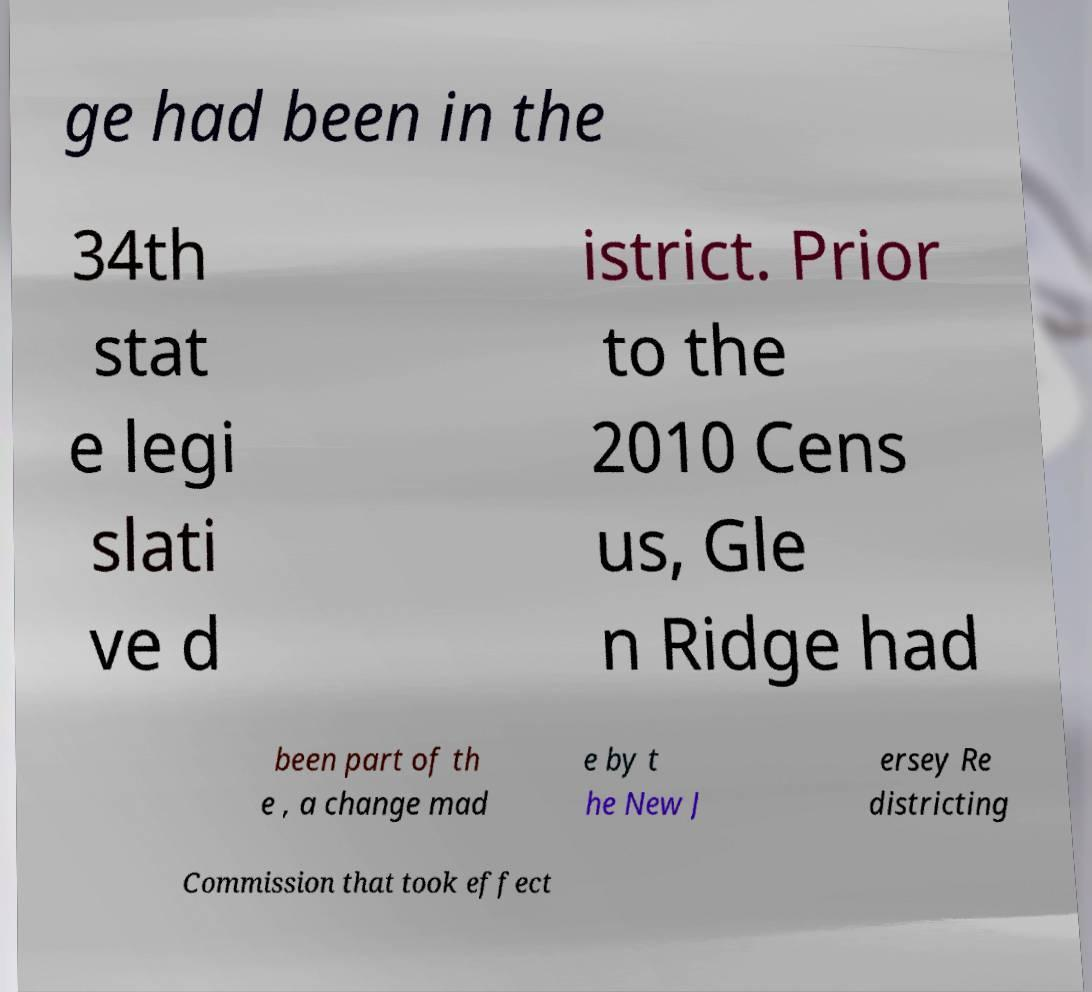Could you extract and type out the text from this image? ge had been in the 34th stat e legi slati ve d istrict. Prior to the 2010 Cens us, Gle n Ridge had been part of th e , a change mad e by t he New J ersey Re districting Commission that took effect 